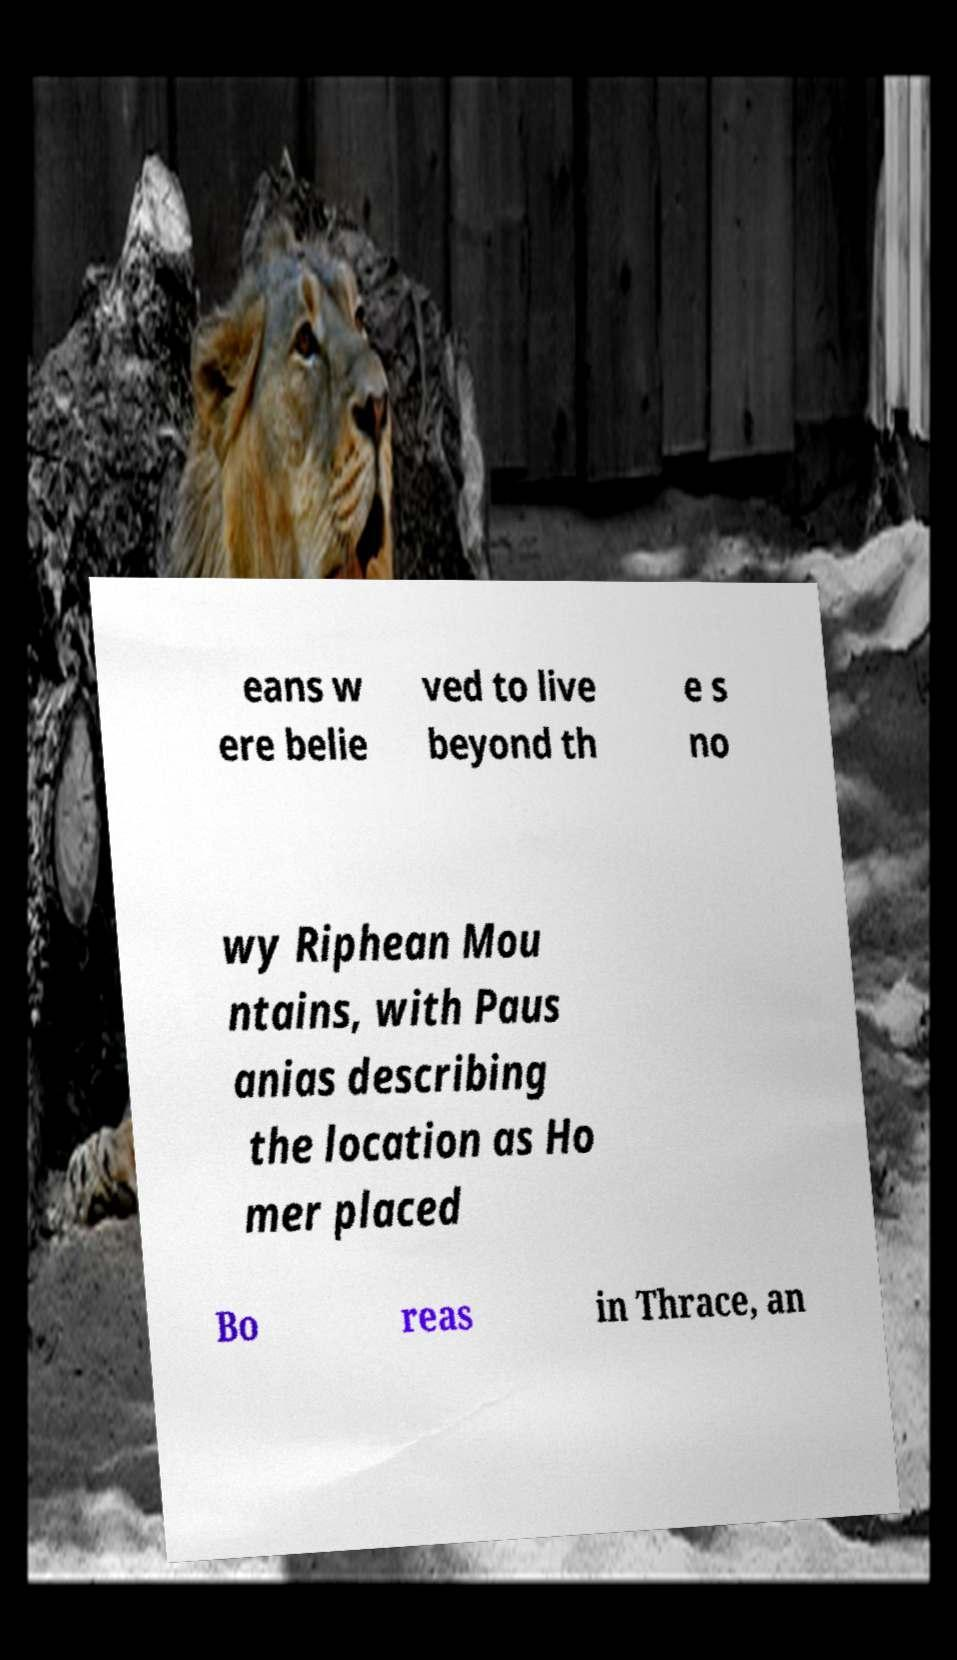Please identify and transcribe the text found in this image. eans w ere belie ved to live beyond th e s no wy Riphean Mou ntains, with Paus anias describing the location as Ho mer placed Bo reas in Thrace, an 